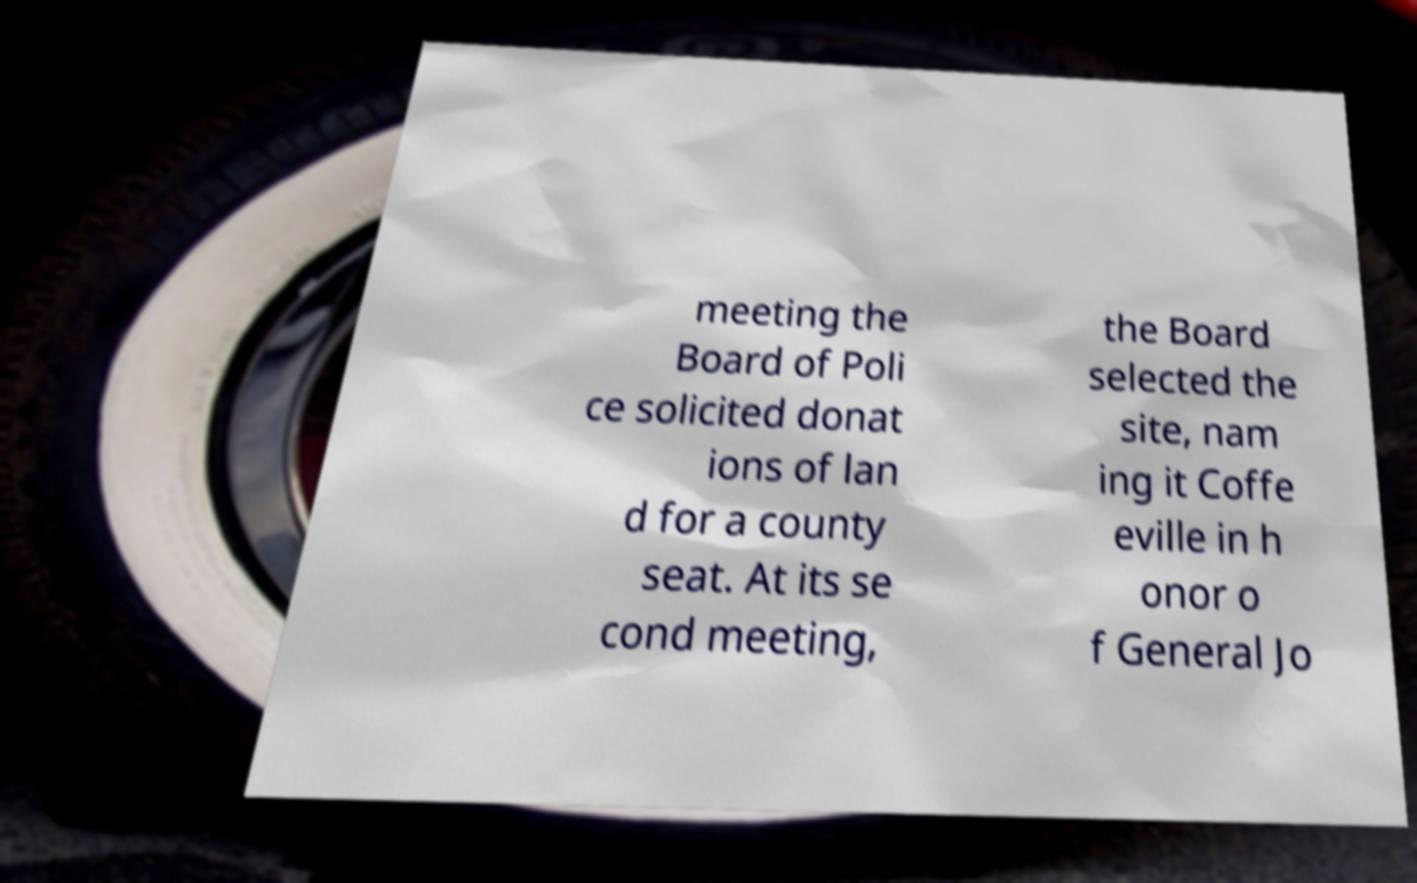There's text embedded in this image that I need extracted. Can you transcribe it verbatim? meeting the Board of Poli ce solicited donat ions of lan d for a county seat. At its se cond meeting, the Board selected the site, nam ing it Coffe eville in h onor o f General Jo 